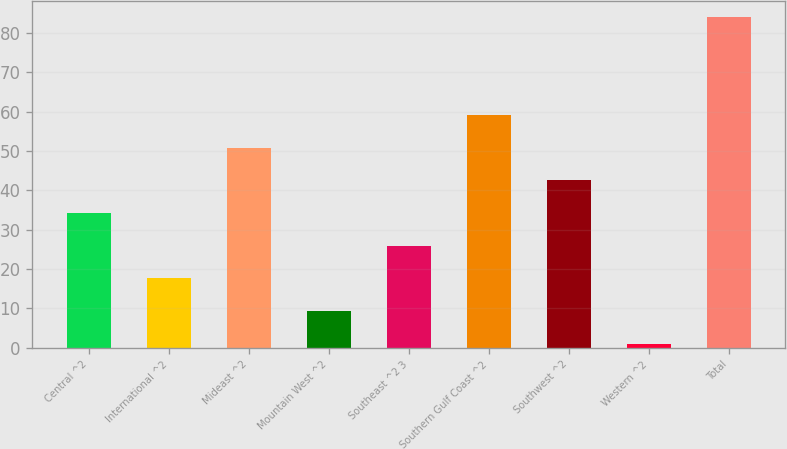<chart> <loc_0><loc_0><loc_500><loc_500><bar_chart><fcel>Central ^2<fcel>International ^2<fcel>Mideast ^2<fcel>Mountain West ^2<fcel>Southeast ^2 3<fcel>Southern Gulf Coast ^2<fcel>Southwest ^2<fcel>Western ^2<fcel>Total<nl><fcel>34.2<fcel>17.6<fcel>50.8<fcel>9.3<fcel>25.9<fcel>59.1<fcel>42.5<fcel>1<fcel>84<nl></chart> 